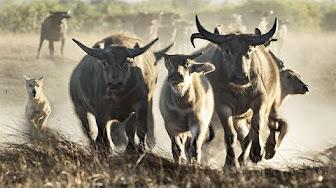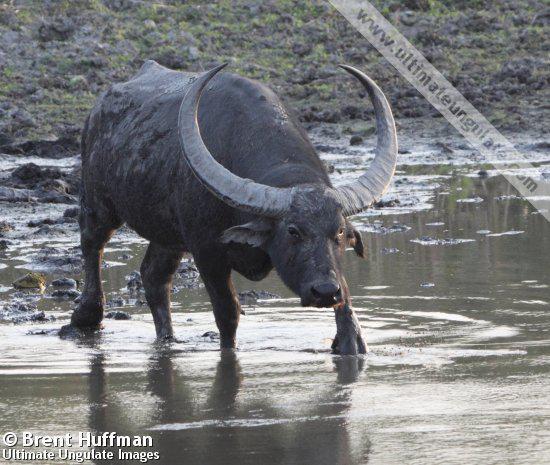The first image is the image on the left, the second image is the image on the right. For the images shown, is this caption "In at least one image there is Least one large horned gray adult bull in the water." true? Answer yes or no. Yes. The first image is the image on the left, the second image is the image on the right. Examine the images to the left and right. Is the description "There are more than three animals total." accurate? Answer yes or no. Yes. 